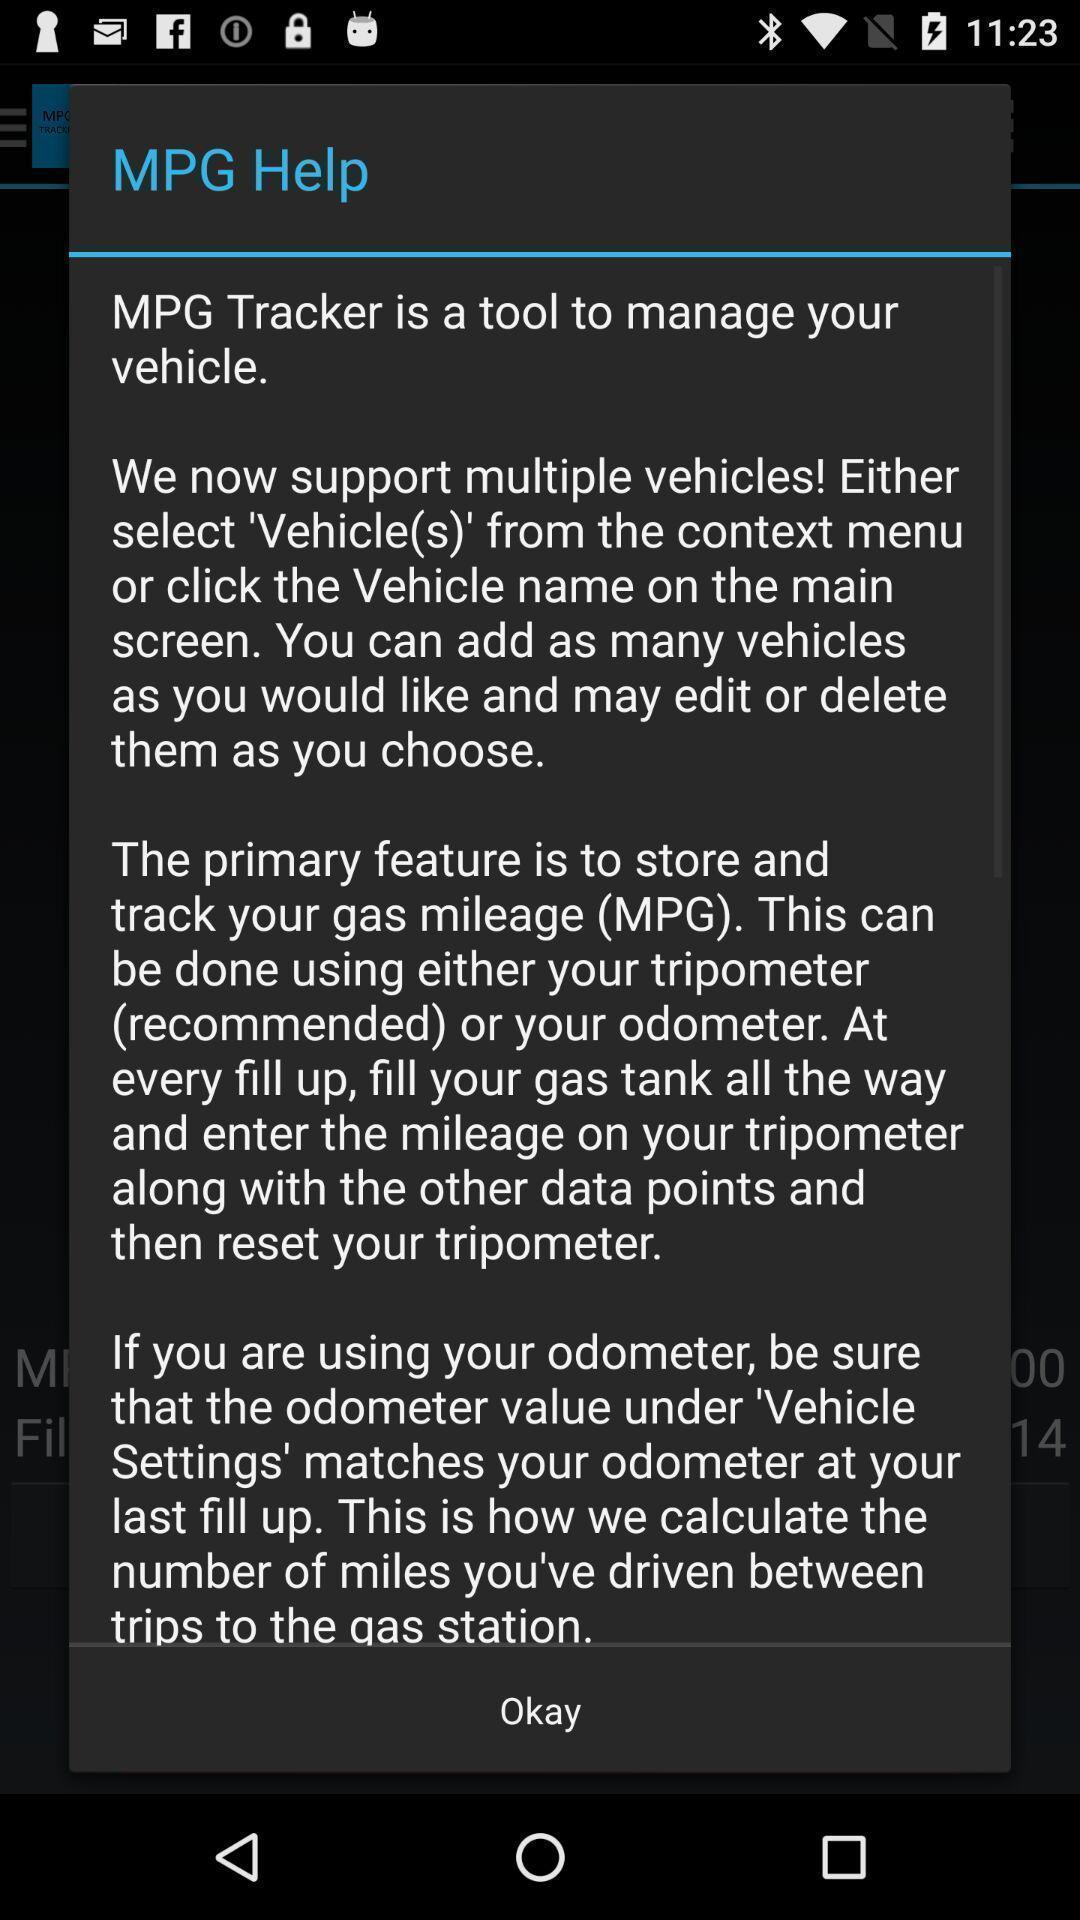What can you discern from this picture? Pop up window for gas app. 